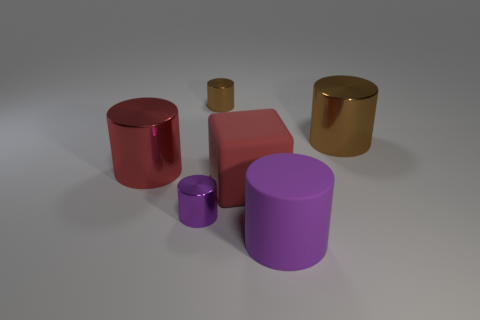There is a large purple thing that is the same shape as the small purple metallic object; what material is it?
Provide a short and direct response. Rubber. Do the purple cylinder behind the large purple cylinder and the purple thing that is right of the small brown cylinder have the same material?
Provide a succinct answer. No. Does the big metallic cylinder that is left of the large brown metal object have the same color as the rubber cube?
Offer a very short reply. Yes. There is a large thing that is behind the red metal thing; what shape is it?
Offer a very short reply. Cylinder. Are there any small things that are in front of the brown cylinder that is left of the large purple thing?
Give a very brief answer. Yes. How many purple objects are the same material as the cube?
Provide a succinct answer. 1. How big is the brown shiny object that is in front of the brown metal cylinder behind the metal object right of the big matte cylinder?
Offer a terse response. Large. There is a purple rubber cylinder; how many small objects are to the left of it?
Your answer should be compact. 2. Are there more big metal cylinders than shiny things?
Your answer should be very brief. No. What is the size of the thing that is the same color as the cube?
Provide a short and direct response. Large. 